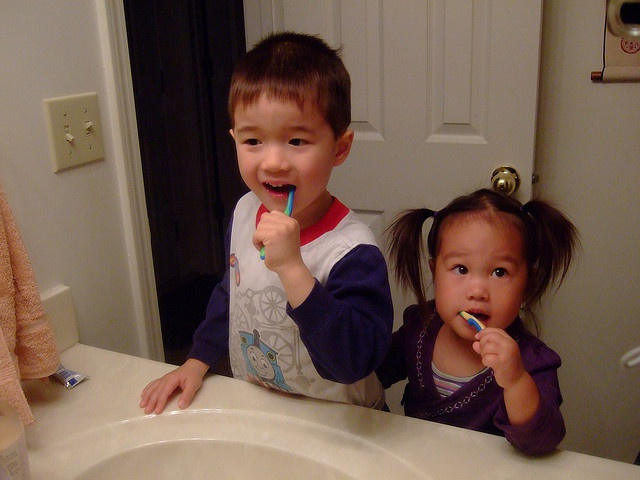Describe the objects in this image and their specific colors. I can see people in gray, black, maroon, and darkgray tones, sink in gray and tan tones, people in gray, black, maroon, and brown tones, toothbrush in gray, tan, blue, and maroon tones, and toothbrush in gray, green, teal, blue, and olive tones in this image. 